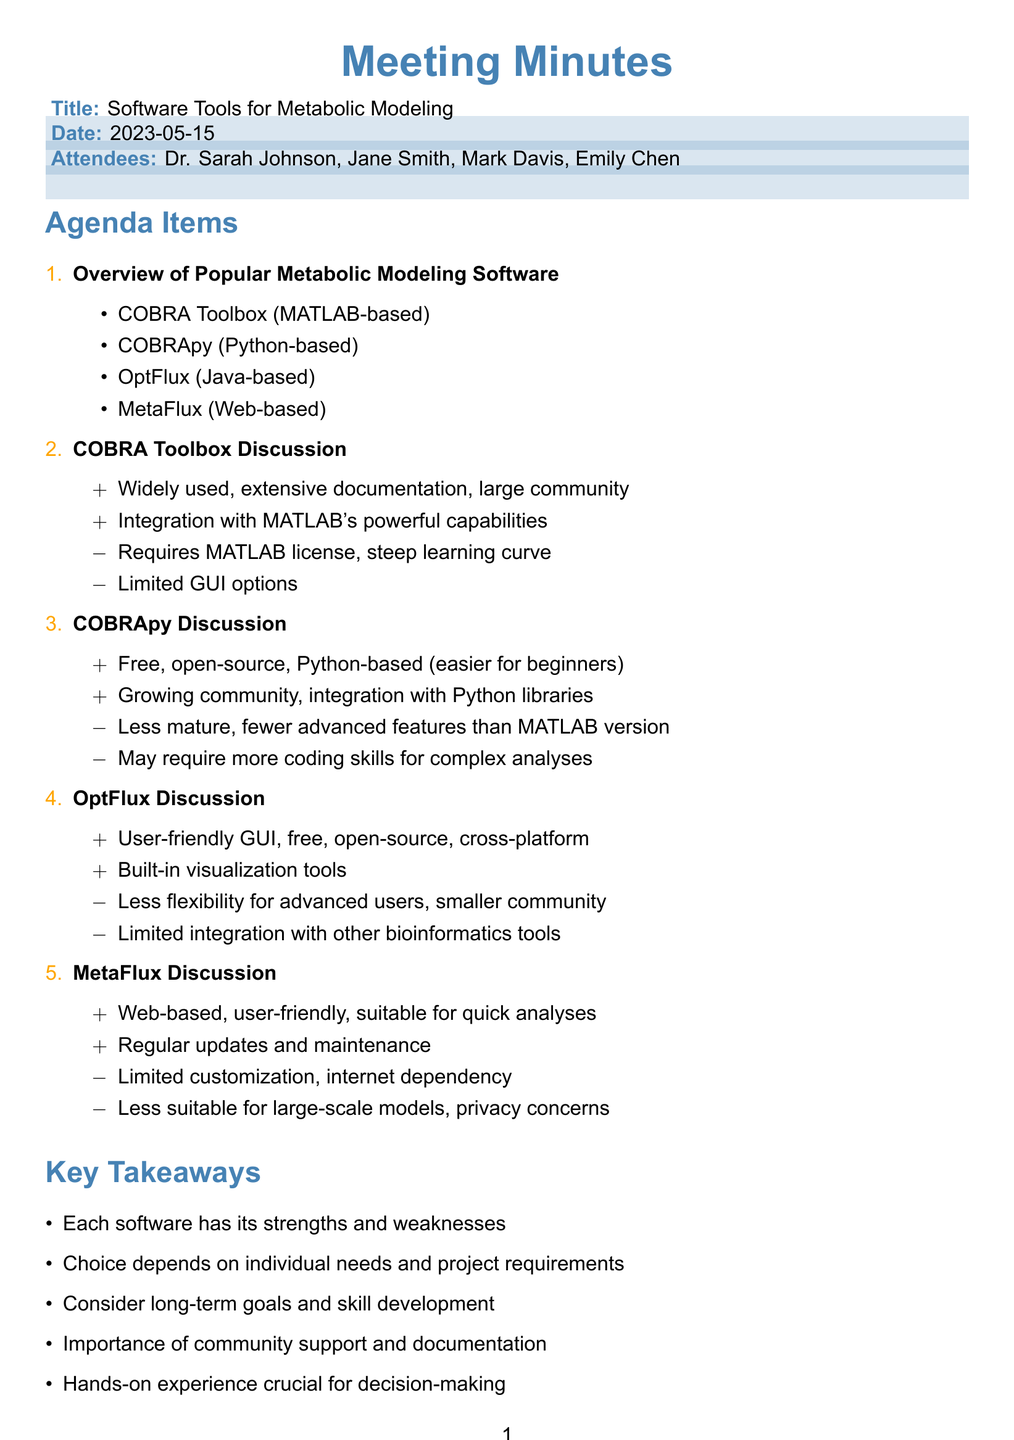What is the title of the meeting? The title of the meeting is stated at the beginning of the document under "Title".
Answer: Software Tools for Metabolic Modeling Who are the attendees? The attendees are listed under the "Attendees" section of the document.
Answer: Dr. Sarah Johnson, Jane Smith, Mark Davis, Emily Chen What is a pro of COBRA Toolbox? The pros of COBRA Toolbox are directly listed under its discussion points in the document.
Answer: Widely used in the field What is a con of COBRApy? The cons of COBRApy are specified in the discussion part of the document.
Answer: Less mature than COBRA Toolbox Which software has a user-friendly GUI? The information about the user-friendly GUI is mentioned in the pros for OptFlux in the document.
Answer: OptFlux What is stated as a consideration for graduate students? The considerations for graduate students are pointed out in a specific agenda item.
Answer: Learning curve and time investment How many software tools were discussed? The total number of software tools can be counted from the "Overview of Popular Metabolic Modeling Software" section.
Answer: Four What is one recommended resource? The recommended resources are detailed under a specific agenda item.
Answer: COBRA Toolbox documentation What are the next steps mentioned? The next steps are listed under a dedicated section of the meeting minutes.
Answer: Schedule software installation workshop 